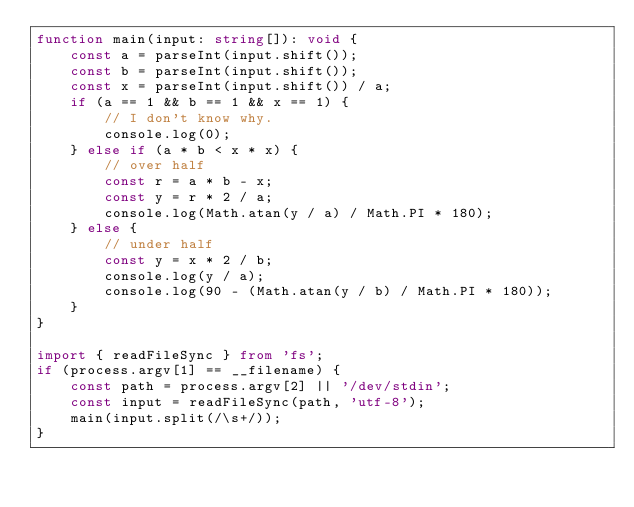<code> <loc_0><loc_0><loc_500><loc_500><_TypeScript_>function main(input: string[]): void {
    const a = parseInt(input.shift());
    const b = parseInt(input.shift());
    const x = parseInt(input.shift()) / a;
    if (a == 1 && b == 1 && x == 1) {
        // I don't know why.
        console.log(0);
    } else if (a * b < x * x) {
        // over half
        const r = a * b - x;
        const y = r * 2 / a;
        console.log(Math.atan(y / a) / Math.PI * 180);
    } else {
        // under half
        const y = x * 2 / b;
        console.log(y / a);
        console.log(90 - (Math.atan(y / b) / Math.PI * 180));
    }
}

import { readFileSync } from 'fs';
if (process.argv[1] == __filename) {
    const path = process.argv[2] || '/dev/stdin';
    const input = readFileSync(path, 'utf-8');
    main(input.split(/\s+/));
}</code> 